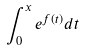Convert formula to latex. <formula><loc_0><loc_0><loc_500><loc_500>\int _ { 0 } ^ { x } e ^ { f ( t ) } d t</formula> 